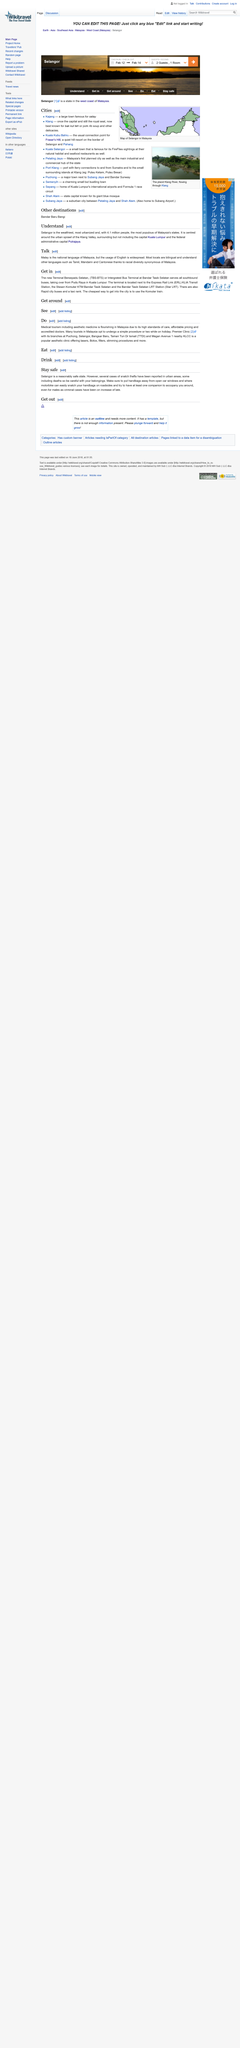Indicate a few pertinent items in this graphic. The most cost-effective method of accessing the city is by taking the Komuter train. It is declared that the national language of Malaysia is Malay. Pudu Raya and Kuala Lumpur are located in the country of Malaysia. 